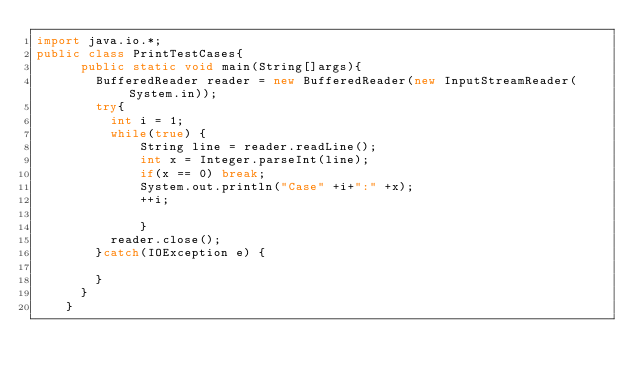<code> <loc_0><loc_0><loc_500><loc_500><_Java_>import java.io.*;
public class PrintTestCases{
		  public static void main(String[]args){
		    BufferedReader reader = new BufferedReader(new InputStreamReader(System.in));
		    try{
		    	int i = 1;
		    	while(true) {
		          String line = reader.readLine();
		          int x = Integer.parseInt(line);
		          if(x == 0) break;
		          System.out.println("Case" +i+":" +x);
		          ++i;
		          
		          }
		    	reader.close();
		    }catch(IOException e) {
		    	
		    }
		  }
		}
</code> 